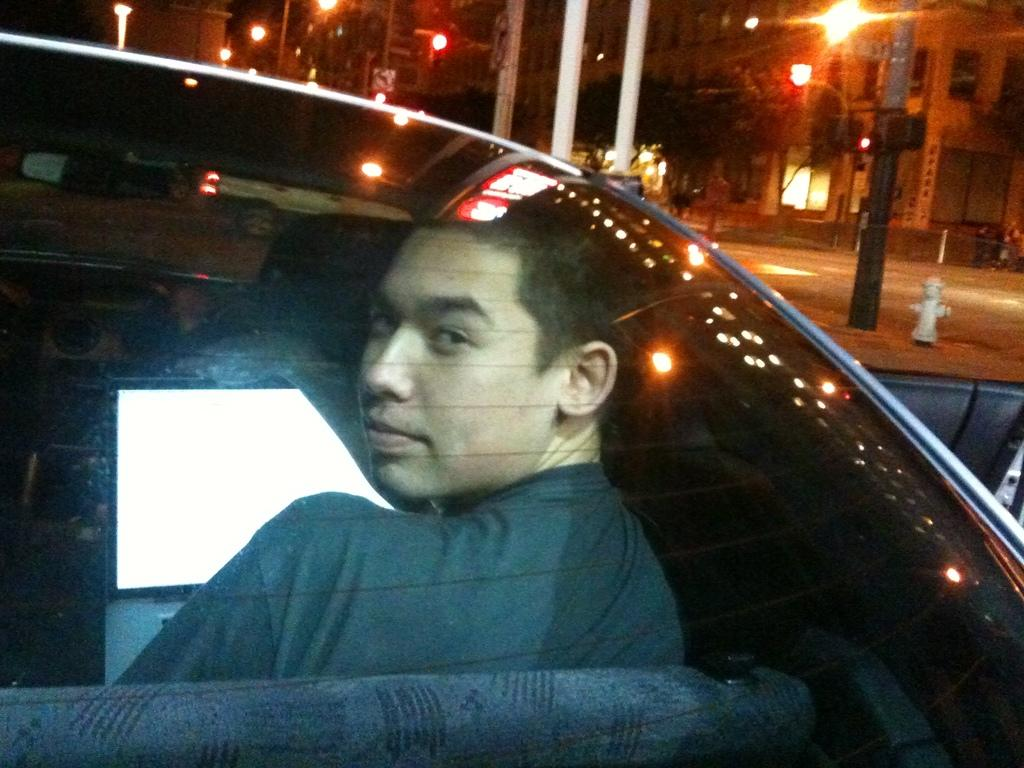What is the man in the image doing? The man is sitting in a car in the image. What can be seen beside the car? There is a surface with poles and lights beside the car. What is visible behind the surface? There is a building with windows visible behind the surface. What type of feather can be seen on the building in the image? There is no feather present on the building in the image. How many cakes are visible on the surface with poles and lights? There are no cakes visible on the surface with poles and lights in the image. 